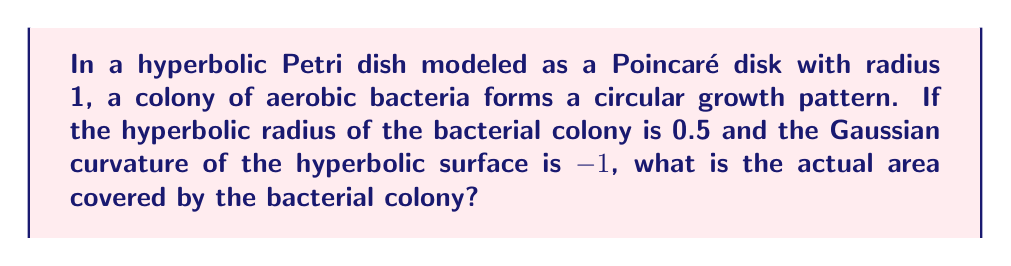Show me your answer to this math problem. To solve this problem, we'll follow these steps:

1) In hyperbolic geometry, the area of a circle is given by the formula:

   $$A = 4\pi \sinh^2(\frac{r}{2})$$

   where $r$ is the hyperbolic radius and $\sinh$ is the hyperbolic sine function.

2) We're given that the hyperbolic radius $r = 0.5$ and the Gaussian curvature $K = -1$.

3) In hyperbolic geometry with curvature $K$, the area formula becomes:

   $$A = \frac{4\pi}{|K|} \sinh^2(\frac{\sqrt{|K|}r}{2})$$

4) Substituting our values:

   $$A = \frac{4\pi}{|-1|} \sinh^2(\frac{\sqrt{|-1|} \cdot 0.5}{2})$$

5) Simplify:

   $$A = 4\pi \sinh^2(0.25)$$

6) Calculate $\sinh(0.25)$:

   $$\sinh(0.25) = \frac{e^{0.25} - e^{-0.25}}{2} \approx 0.25261$$

7) Square this value:

   $$\sinh^2(0.25) \approx 0.06381$$

8) Multiply by $4\pi$:

   $$A \approx 4\pi \cdot 0.06381 \approx 0.80137$$

Therefore, the area covered by the bacterial colony is approximately 0.80137 square units in the hyperbolic plane.
Answer: $$0.80137$$ 